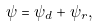Convert formula to latex. <formula><loc_0><loc_0><loc_500><loc_500>\psi = \psi _ { d } + \psi _ { r } ,</formula> 